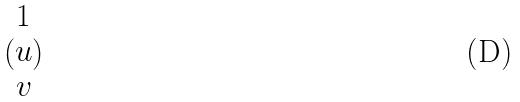Convert formula to latex. <formula><loc_0><loc_0><loc_500><loc_500>( \begin{matrix} 1 \\ u \\ v \end{matrix} )</formula> 